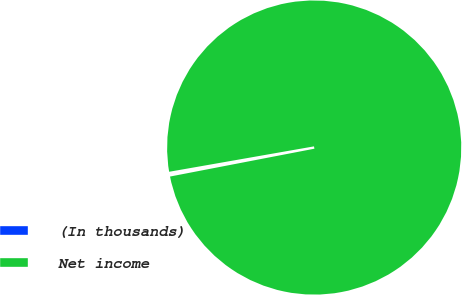Convert chart. <chart><loc_0><loc_0><loc_500><loc_500><pie_chart><fcel>(In thousands)<fcel>Net income<nl><fcel>0.27%<fcel>99.73%<nl></chart> 